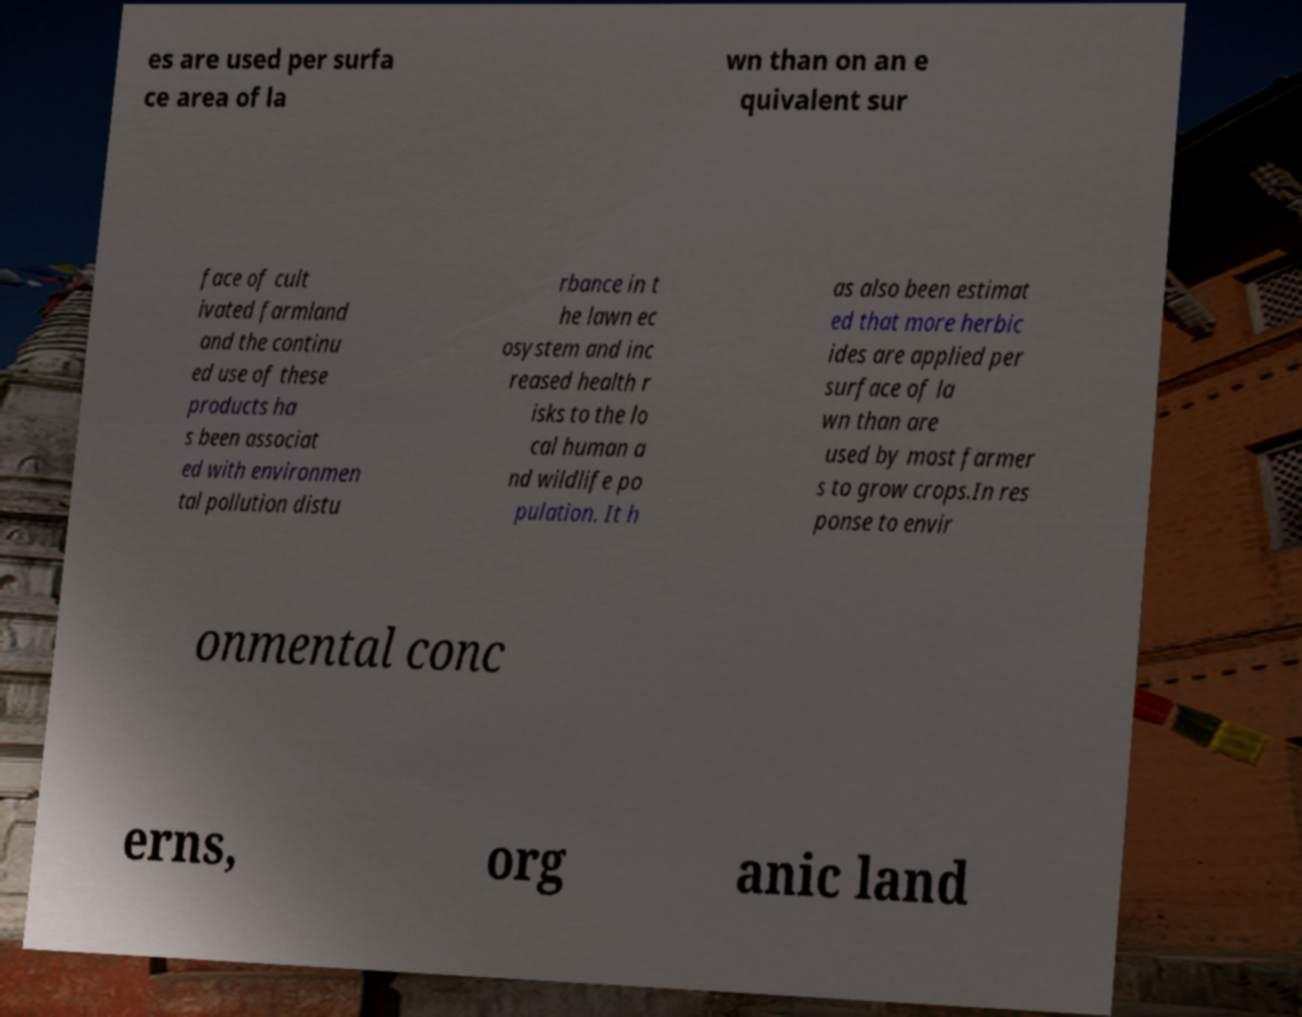Can you read and provide the text displayed in the image?This photo seems to have some interesting text. Can you extract and type it out for me? es are used per surfa ce area of la wn than on an e quivalent sur face of cult ivated farmland and the continu ed use of these products ha s been associat ed with environmen tal pollution distu rbance in t he lawn ec osystem and inc reased health r isks to the lo cal human a nd wildlife po pulation. It h as also been estimat ed that more herbic ides are applied per surface of la wn than are used by most farmer s to grow crops.In res ponse to envir onmental conc erns, org anic land 